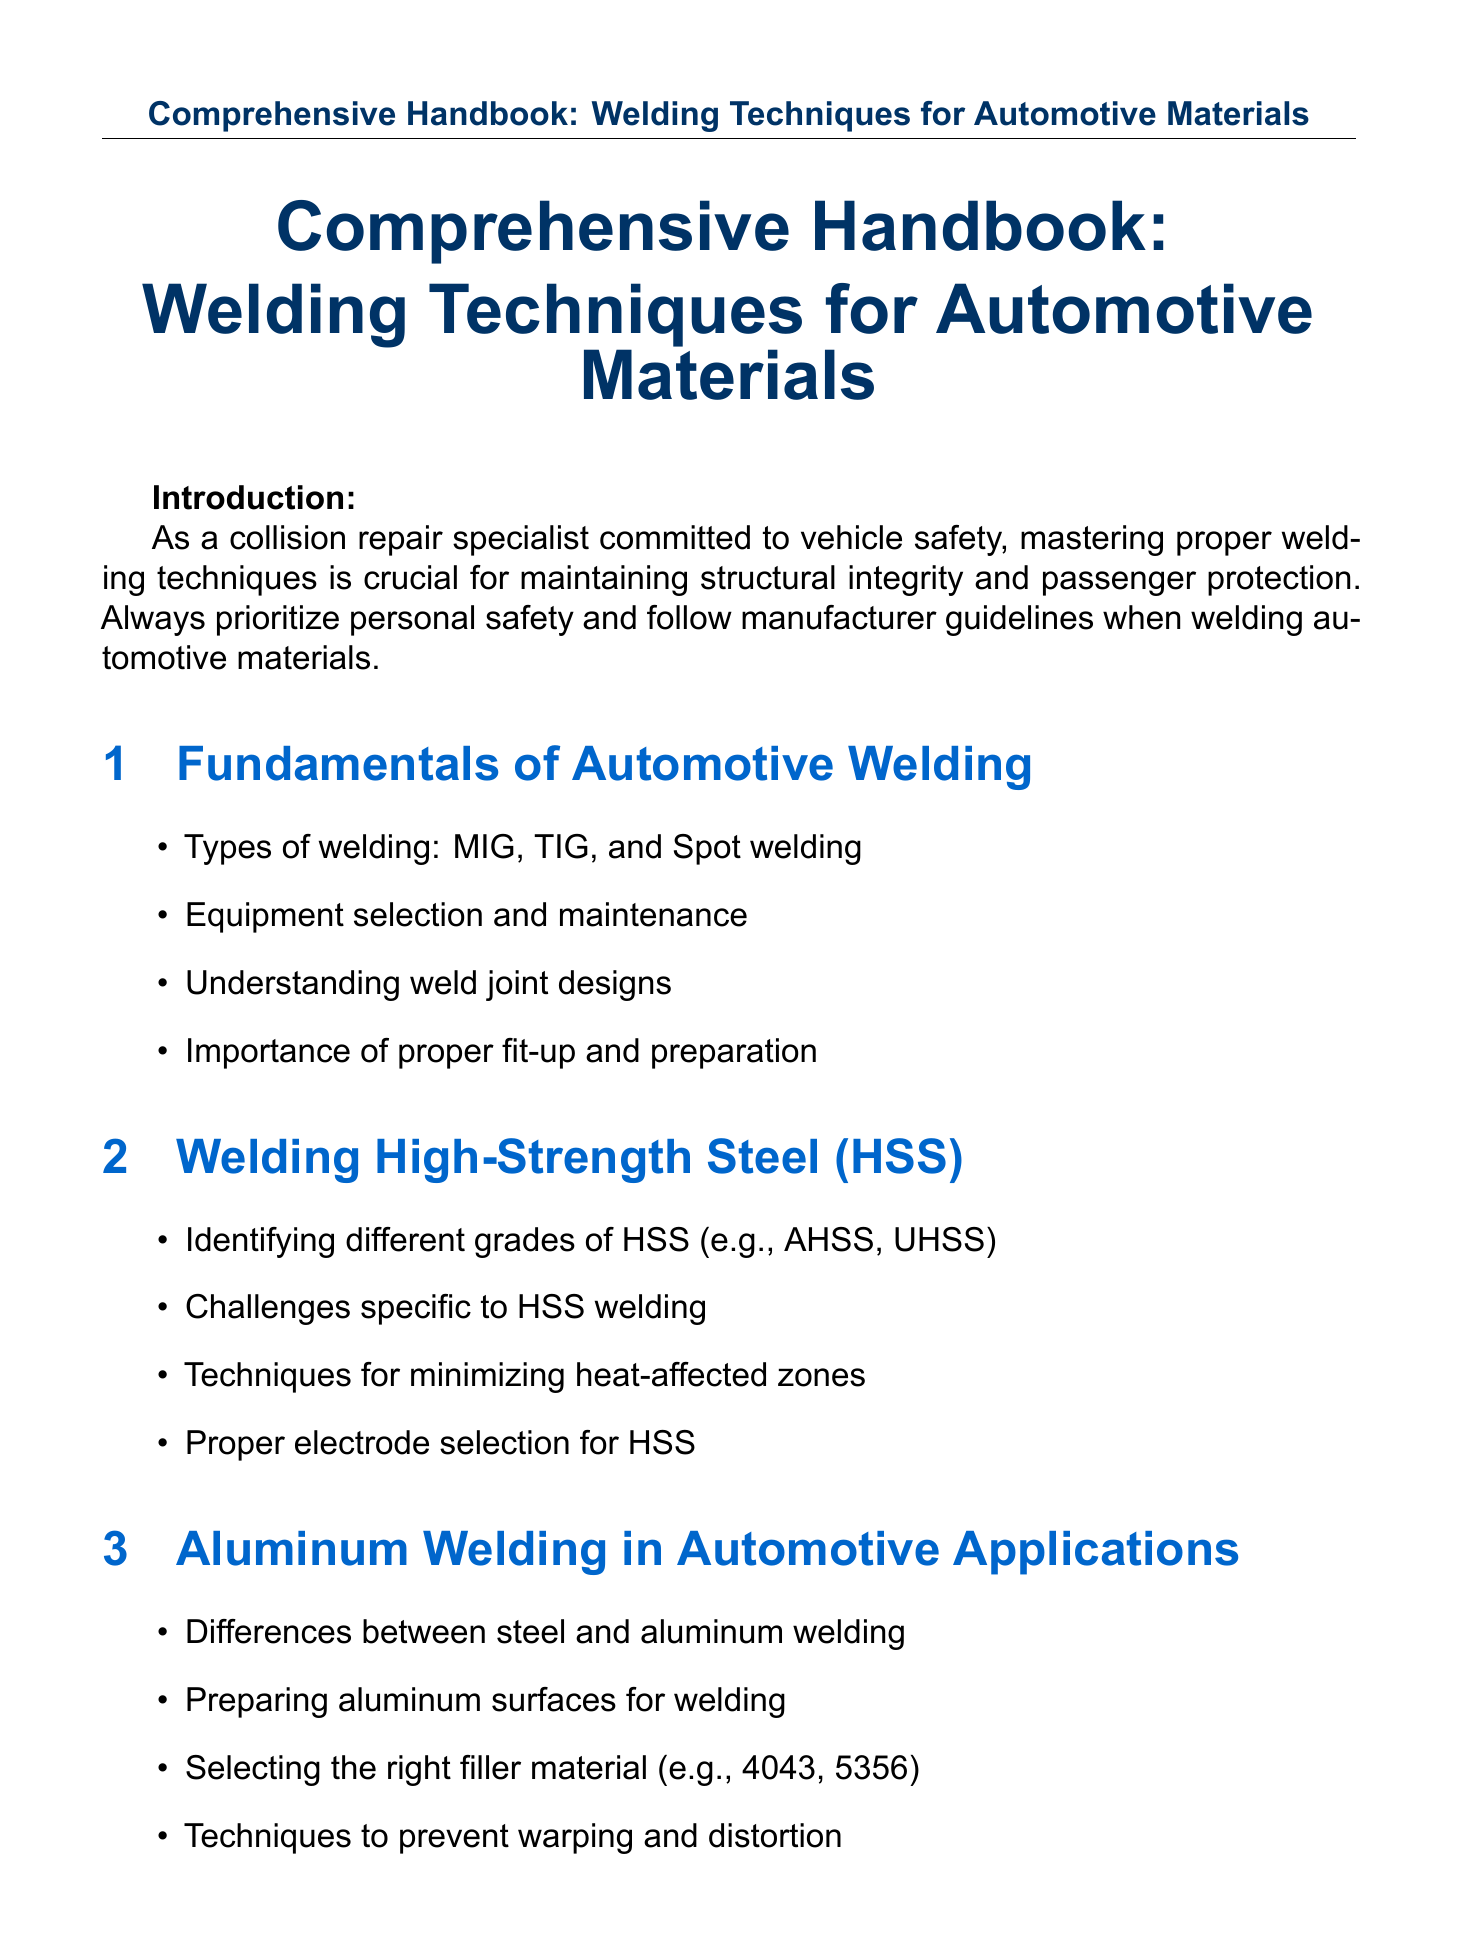What are the types of welding discussed? The document outlines various welding types including MIG, TIG, and Spot welding.
Answer: MIG, TIG, Spot welding What is the main safety note for welding? The document emphasizes prioritizing personal safety and adhering to manufacturer guidelines when welding.
Answer: Personal safety Which grades are identified under High-Strength Steel? The handbook mentions AHSS and UHSS as examples of different grades of HSS.
Answer: AHSS, UHSS What is a specific technique for aluminum welding? The document lists preparing aluminum surfaces for welding as a key technique in aluminum welding.
Answer: Preparing surfaces Name one advanced welding technique mentioned. Pulse MIG welding, Cold Metal Transfer, laser welding, and friction stir welding are all referenced.
Answer: Pulse MIG welding What are two non-destructive testing methods? The document specifies ultrasonic and X-ray testing as methods of non-destructive testing.
Answer: Ultrasonic, X-ray Which vehicle is noted for an aluminum-intensive body structure? The document discusses Tesla's body structures as a notable example of aluminum-intensive design.
Answer: Tesla What is included in the PPE checklist? The checklist contains items such as welding helmets, gloves, jackets, and steel-toe boots.
Answer: Welding helmet, gloves, jacket, boots How many welding certification programs are listed? The handbook contains three certification resources provided within the appendices.
Answer: Three 